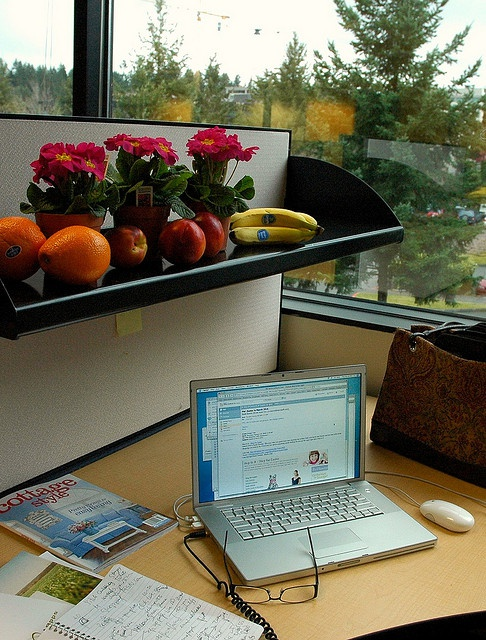Describe the objects in this image and their specific colors. I can see laptop in ivory, darkgray, gray, lightgray, and teal tones, handbag in ivory, black, maroon, darkgray, and gray tones, book in ivory, gray, darkgray, blue, and black tones, potted plant in ivory, black, maroon, brown, and gray tones, and potted plant in ivory, black, maroon, darkgray, and brown tones in this image. 